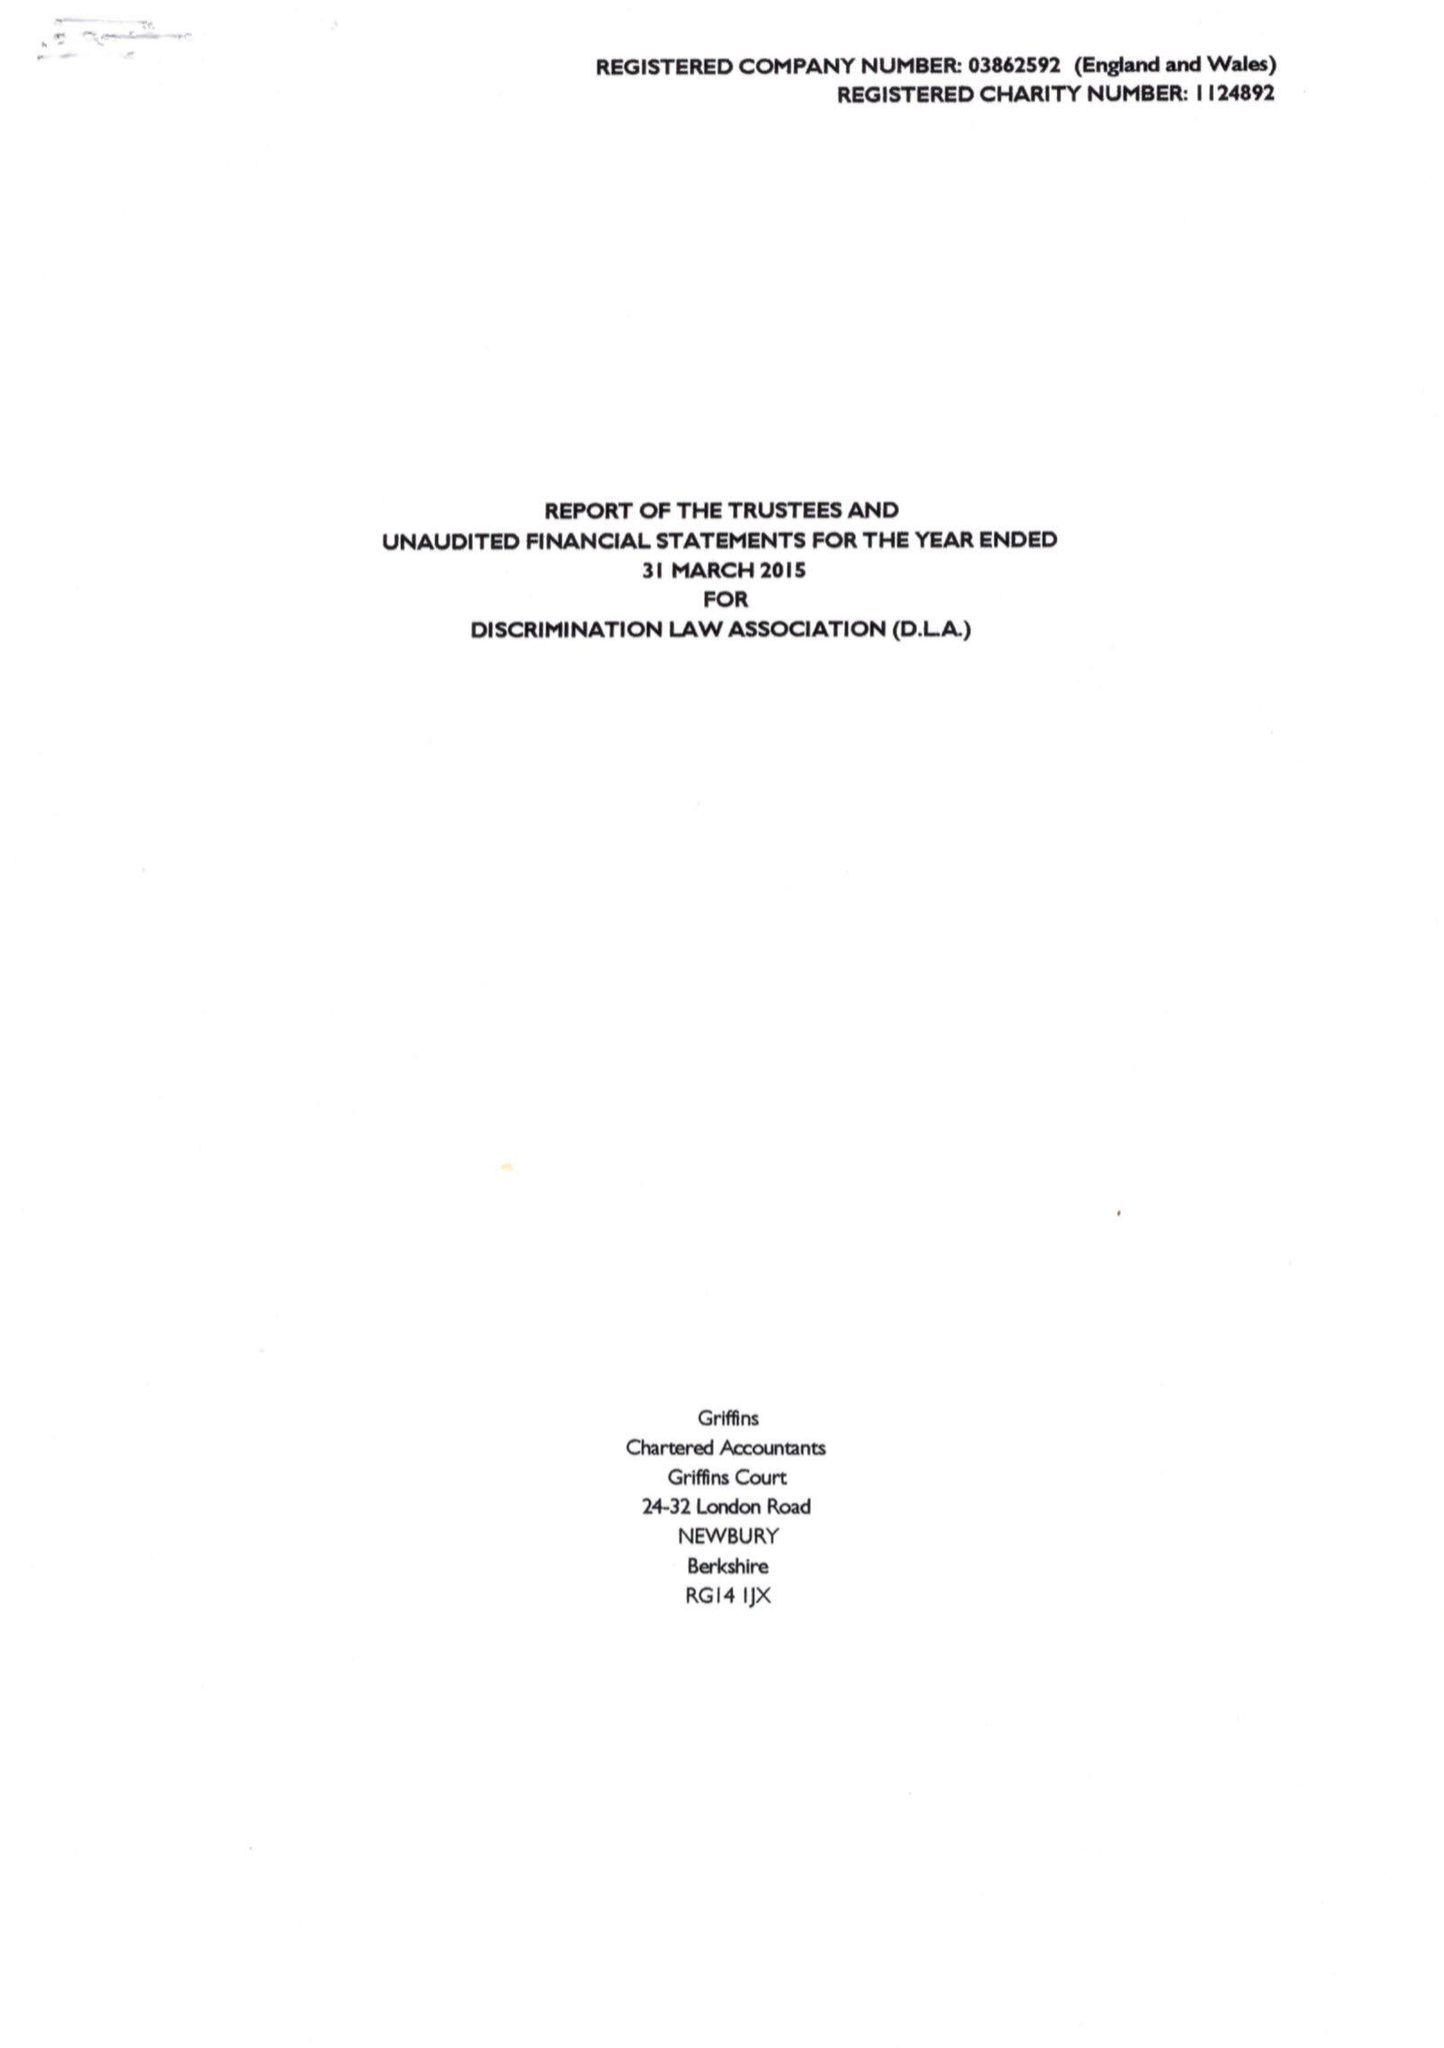What is the value for the charity_number?
Answer the question using a single word or phrase. 1124892 